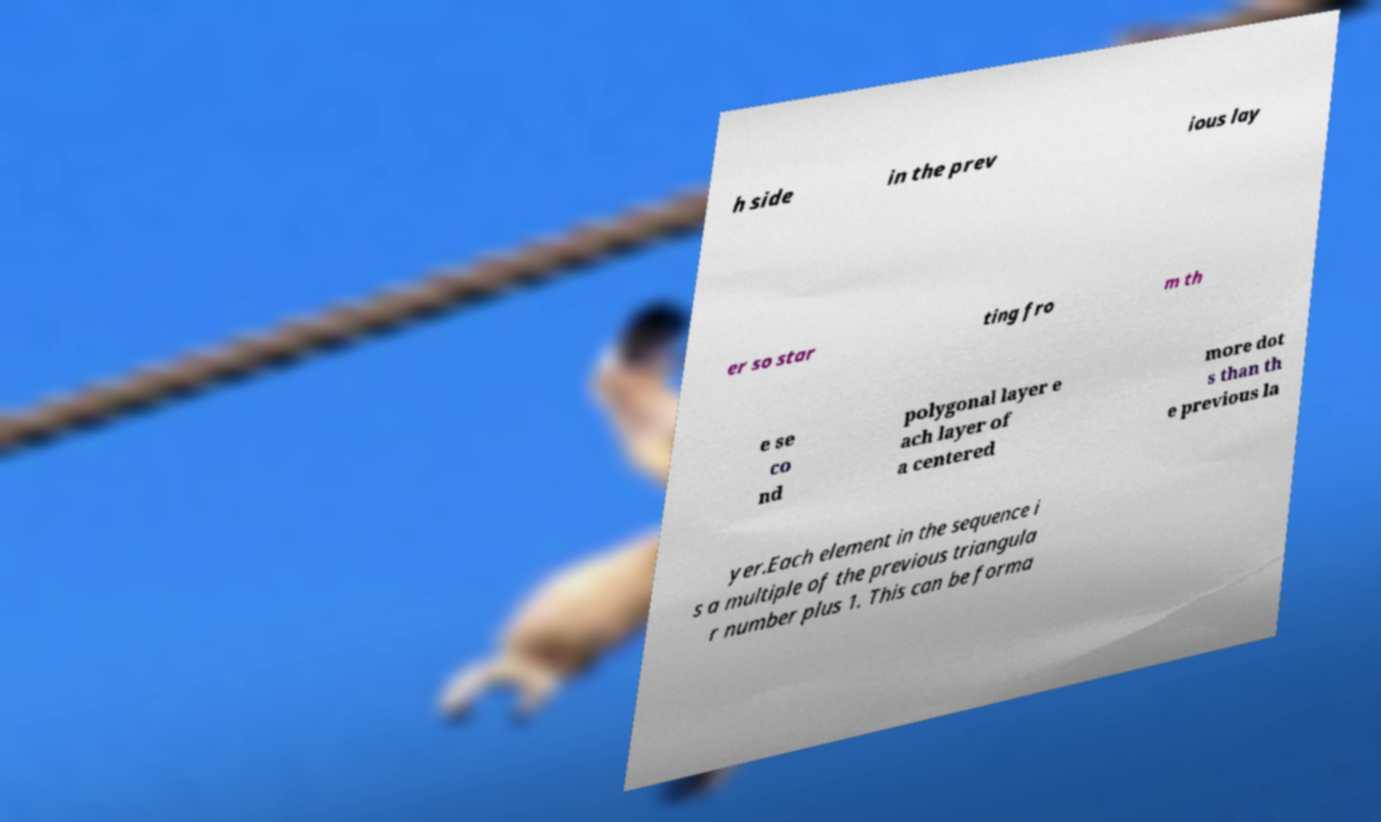For documentation purposes, I need the text within this image transcribed. Could you provide that? h side in the prev ious lay er so star ting fro m th e se co nd polygonal layer e ach layer of a centered more dot s than th e previous la yer.Each element in the sequence i s a multiple of the previous triangula r number plus 1. This can be forma 